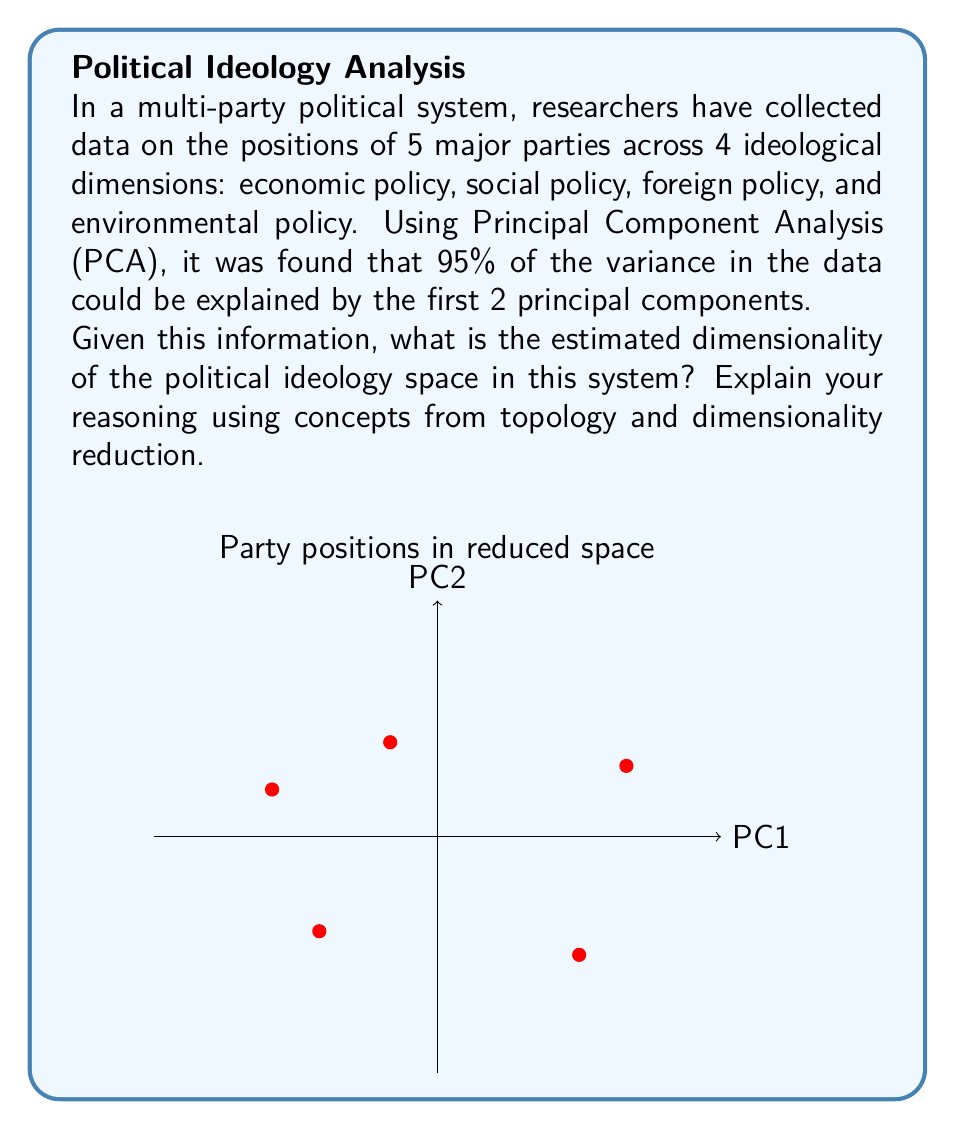Can you answer this question? To determine the dimensionality of political ideologies in this multi-party system, we need to consider the following steps:

1. Initial dimensionality: The data was collected across 4 ideological dimensions, so the original space had 4 dimensions.

2. Principal Component Analysis (PCA): This is a dimensionality reduction technique that identifies the directions (principal components) along which the data varies the most.

3. Variance explained: The key information is that 95% of the variance is explained by the first 2 principal components. In topology and manifold learning, this suggests that the data lies close to a lower-dimensional subspace or manifold.

4. Intrinsic dimensionality: The number of dimensions needed to represent the data without significant loss of information is often considered the intrinsic dimensionality. 

5. Elbow method: In PCA, the "elbow" in the scree plot (percentage of variance explained vs. number of components) is often used to estimate intrinsic dimensionality. Here, we have a sharp elbow at 2 components.

6. Topological perspective: From a topological viewpoint, we're looking for a lower-dimensional manifold that approximates the data cloud in the higher-dimensional space. The fact that 2 dimensions capture 95% of the variance suggests that this manifold is close to 2-dimensional.

7. Error tolerance: The 5% of variance not explained by the first 2 components could be attributed to noise or minor variations. In many applications, a 95% threshold is considered sufficient for dimensionality estimation.

Therefore, despite the original 4-dimensional data, the political ideology space in this system can be well-approximated by a 2-dimensional subspace. This suggests that two main factors or axes can explain most of the variation in party positions, which could be interpreted as the primary ideological divisions in this political landscape.

The estimated dimensionality is thus 2, reflecting a significant reduction from the original 4 dimensions while retaining most of the information about party positions.
Answer: 2 